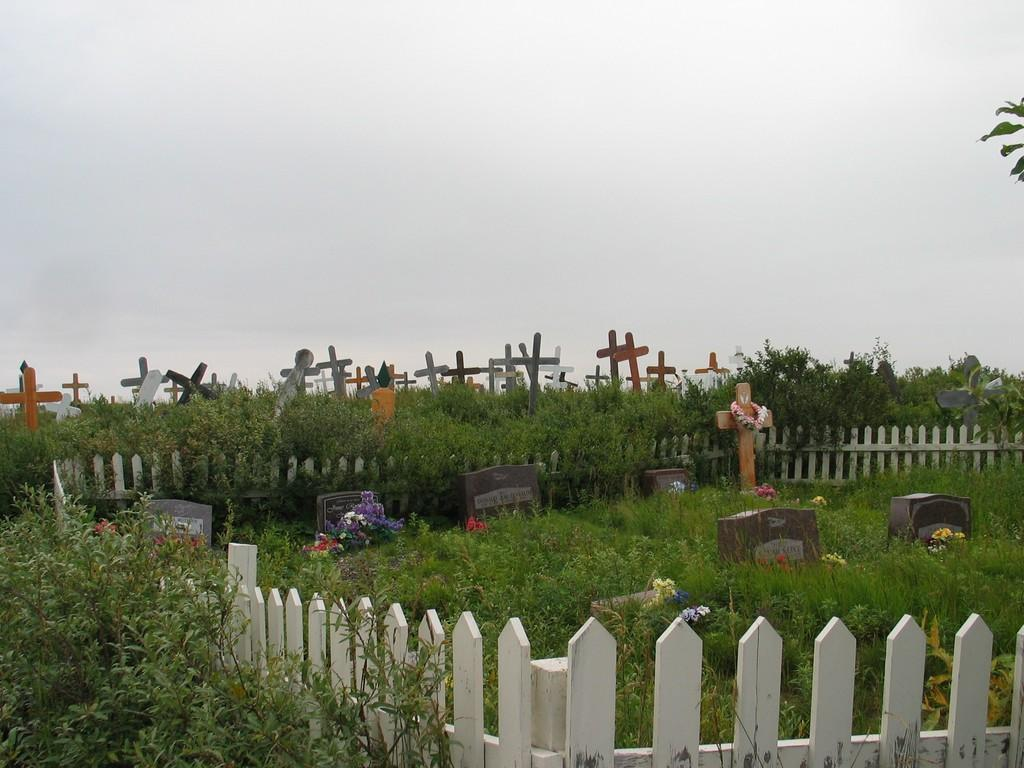What type of location is depicted in the image? The image depicts a cemetery. What can be seen on the graves in the cemetery? There are many crosses in the cemetery. Are there any decorations or offerings in the cemetery? Yes, flowers are present in the cemetery. What type of vegetation is present in the cemetery? There are plants in the cemetery. What is visible in the background of the image? The sky is visible in the background of the image. What type of crack can be seen on the shoes of the person walking in the cemetery? There is no person or shoes visible in the image; it depicts a cemetery with crosses, flowers, plants, and a visible sky. What suggestion is given by the person in the cemetery? There is no person present in the image to give any suggestions. 